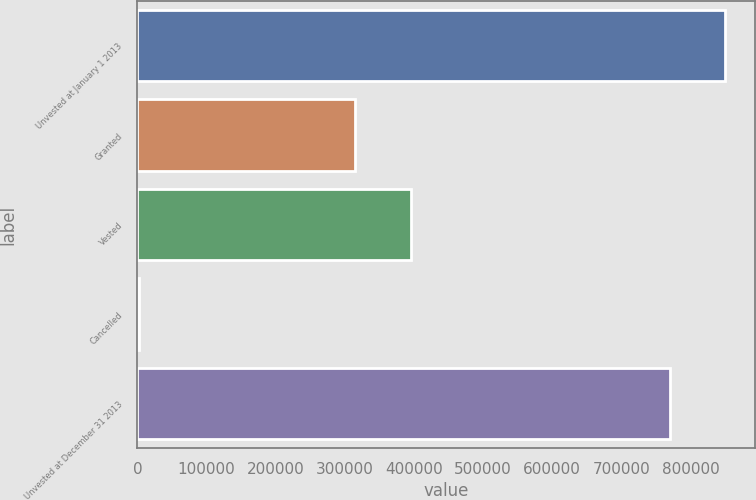Convert chart. <chart><loc_0><loc_0><loc_500><loc_500><bar_chart><fcel>Unvested at January 1 2013<fcel>Granted<fcel>Vested<fcel>Cancelled<fcel>Unvested at December 31 2013<nl><fcel>850516<fcel>315316<fcel>395002<fcel>2633<fcel>770830<nl></chart> 